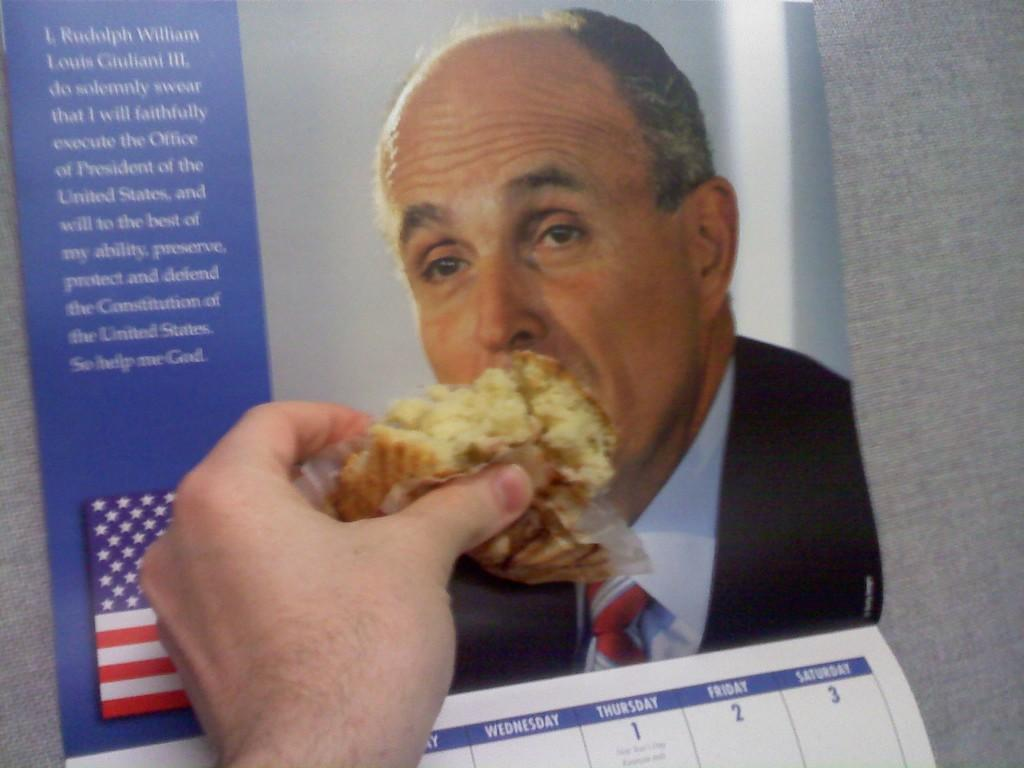<image>
Provide a brief description of the given image. A calendar with a picture of Rudy Giuliani on it. 